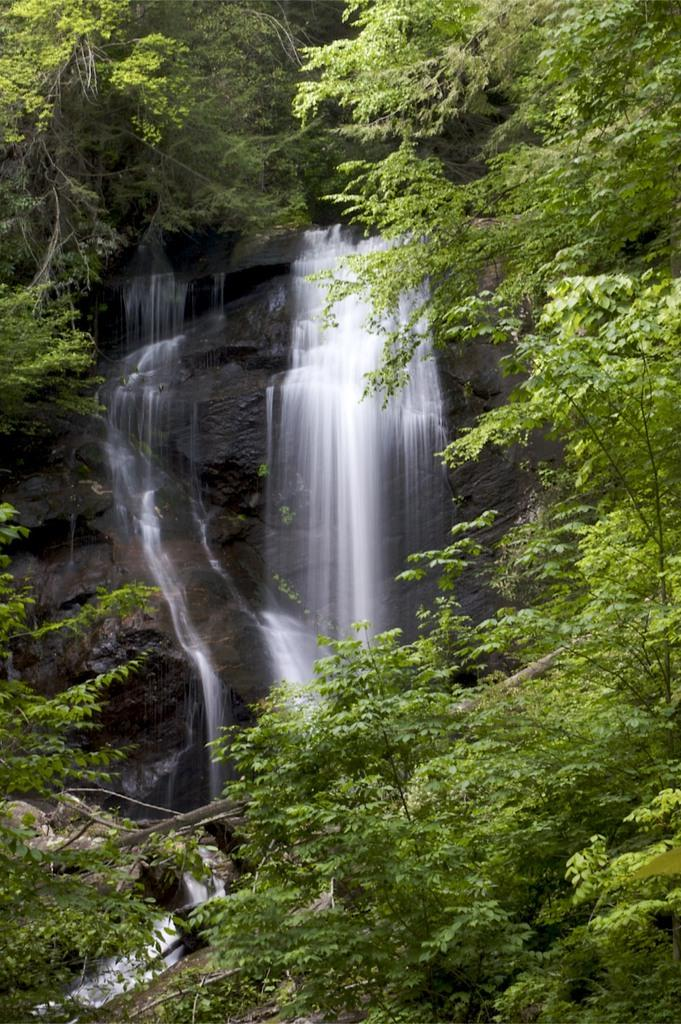What is the main subject of the image? The main subject of the image is a waterfall. Where is the waterfall located in the image? The waterfall is in the middle of the image. What can be seen around the waterfall? The waterfall is surrounded by many trees. What type of cheese is being used by the spy in the image? There is no spy or cheese present in the image; it features a waterfall surrounded by trees. 